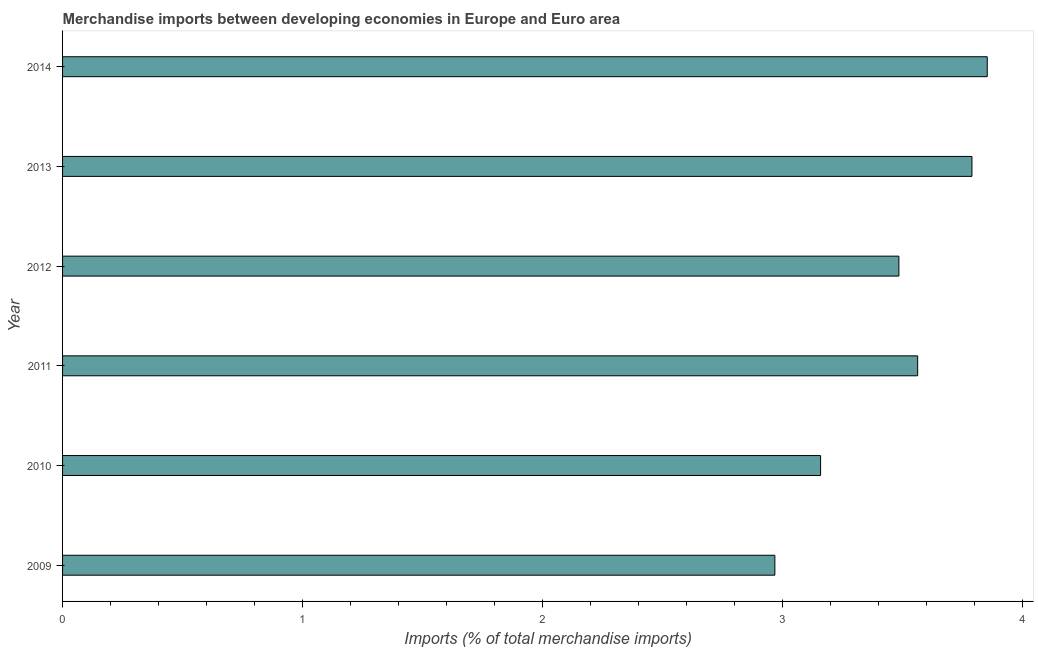What is the title of the graph?
Provide a short and direct response. Merchandise imports between developing economies in Europe and Euro area. What is the label or title of the X-axis?
Give a very brief answer. Imports (% of total merchandise imports). What is the merchandise imports in 2013?
Your response must be concise. 3.79. Across all years, what is the maximum merchandise imports?
Make the answer very short. 3.85. Across all years, what is the minimum merchandise imports?
Give a very brief answer. 2.97. In which year was the merchandise imports maximum?
Your response must be concise. 2014. What is the sum of the merchandise imports?
Offer a very short reply. 20.81. What is the difference between the merchandise imports in 2011 and 2013?
Make the answer very short. -0.23. What is the average merchandise imports per year?
Your answer should be compact. 3.47. What is the median merchandise imports?
Your answer should be very brief. 3.52. Do a majority of the years between 2014 and 2011 (inclusive) have merchandise imports greater than 1 %?
Offer a very short reply. Yes. Is the difference between the merchandise imports in 2009 and 2010 greater than the difference between any two years?
Ensure brevity in your answer.  No. What is the difference between the highest and the second highest merchandise imports?
Provide a succinct answer. 0.06. What is the difference between the highest and the lowest merchandise imports?
Provide a succinct answer. 0.88. How many bars are there?
Your answer should be compact. 6. Are all the bars in the graph horizontal?
Your answer should be compact. Yes. How many years are there in the graph?
Keep it short and to the point. 6. What is the difference between two consecutive major ticks on the X-axis?
Ensure brevity in your answer.  1. What is the Imports (% of total merchandise imports) in 2009?
Provide a succinct answer. 2.97. What is the Imports (% of total merchandise imports) in 2010?
Your response must be concise. 3.16. What is the Imports (% of total merchandise imports) of 2011?
Provide a succinct answer. 3.56. What is the Imports (% of total merchandise imports) of 2012?
Ensure brevity in your answer.  3.48. What is the Imports (% of total merchandise imports) in 2013?
Offer a terse response. 3.79. What is the Imports (% of total merchandise imports) of 2014?
Provide a succinct answer. 3.85. What is the difference between the Imports (% of total merchandise imports) in 2009 and 2010?
Your answer should be compact. -0.19. What is the difference between the Imports (% of total merchandise imports) in 2009 and 2011?
Offer a very short reply. -0.59. What is the difference between the Imports (% of total merchandise imports) in 2009 and 2012?
Give a very brief answer. -0.52. What is the difference between the Imports (% of total merchandise imports) in 2009 and 2013?
Offer a terse response. -0.82. What is the difference between the Imports (% of total merchandise imports) in 2009 and 2014?
Offer a terse response. -0.88. What is the difference between the Imports (% of total merchandise imports) in 2010 and 2011?
Offer a very short reply. -0.4. What is the difference between the Imports (% of total merchandise imports) in 2010 and 2012?
Make the answer very short. -0.33. What is the difference between the Imports (% of total merchandise imports) in 2010 and 2013?
Make the answer very short. -0.63. What is the difference between the Imports (% of total merchandise imports) in 2010 and 2014?
Offer a terse response. -0.69. What is the difference between the Imports (% of total merchandise imports) in 2011 and 2012?
Offer a very short reply. 0.08. What is the difference between the Imports (% of total merchandise imports) in 2011 and 2013?
Keep it short and to the point. -0.23. What is the difference between the Imports (% of total merchandise imports) in 2011 and 2014?
Provide a succinct answer. -0.29. What is the difference between the Imports (% of total merchandise imports) in 2012 and 2013?
Provide a short and direct response. -0.3. What is the difference between the Imports (% of total merchandise imports) in 2012 and 2014?
Ensure brevity in your answer.  -0.37. What is the difference between the Imports (% of total merchandise imports) in 2013 and 2014?
Ensure brevity in your answer.  -0.06. What is the ratio of the Imports (% of total merchandise imports) in 2009 to that in 2011?
Make the answer very short. 0.83. What is the ratio of the Imports (% of total merchandise imports) in 2009 to that in 2012?
Make the answer very short. 0.85. What is the ratio of the Imports (% of total merchandise imports) in 2009 to that in 2013?
Give a very brief answer. 0.78. What is the ratio of the Imports (% of total merchandise imports) in 2009 to that in 2014?
Offer a very short reply. 0.77. What is the ratio of the Imports (% of total merchandise imports) in 2010 to that in 2011?
Your response must be concise. 0.89. What is the ratio of the Imports (% of total merchandise imports) in 2010 to that in 2012?
Provide a short and direct response. 0.91. What is the ratio of the Imports (% of total merchandise imports) in 2010 to that in 2013?
Your answer should be very brief. 0.83. What is the ratio of the Imports (% of total merchandise imports) in 2010 to that in 2014?
Give a very brief answer. 0.82. What is the ratio of the Imports (% of total merchandise imports) in 2011 to that in 2012?
Provide a short and direct response. 1.02. What is the ratio of the Imports (% of total merchandise imports) in 2011 to that in 2014?
Your response must be concise. 0.93. What is the ratio of the Imports (% of total merchandise imports) in 2012 to that in 2014?
Offer a very short reply. 0.9. What is the ratio of the Imports (% of total merchandise imports) in 2013 to that in 2014?
Offer a terse response. 0.98. 